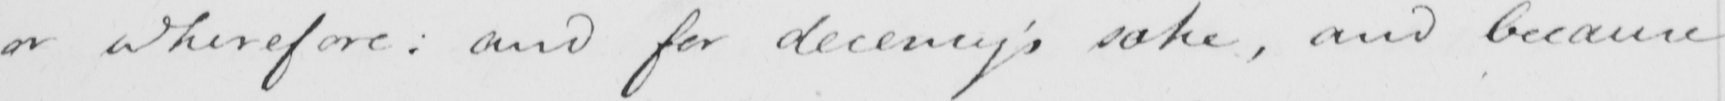What is written in this line of handwriting? or wherefore :  and for decency ' s sake , and because 